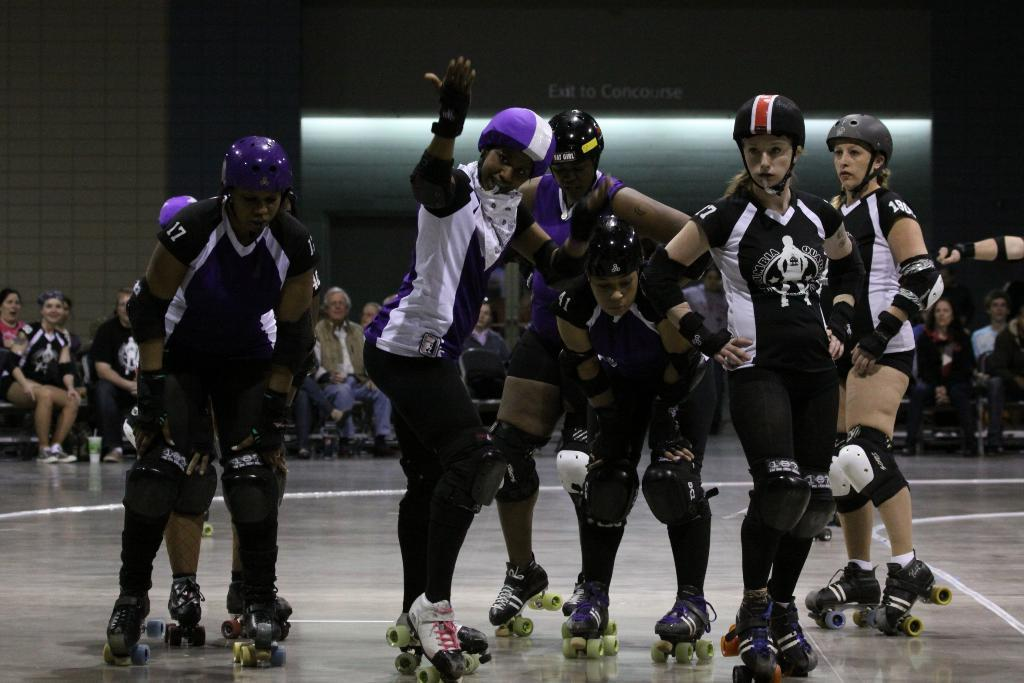What are the people in the front of the image doing? The people standing in the front of the image are wearing skate shoes. Can you describe the people in the back of the image? The people sitting in the back of the image are not described in the provided facts. What type of footwear are the people in the front wearing? The people standing in the front of the image are wearing skate shoes. How many oranges are being counted by the people in the image? There is no mention of oranges in the image, so it is not possible to answer that question. 